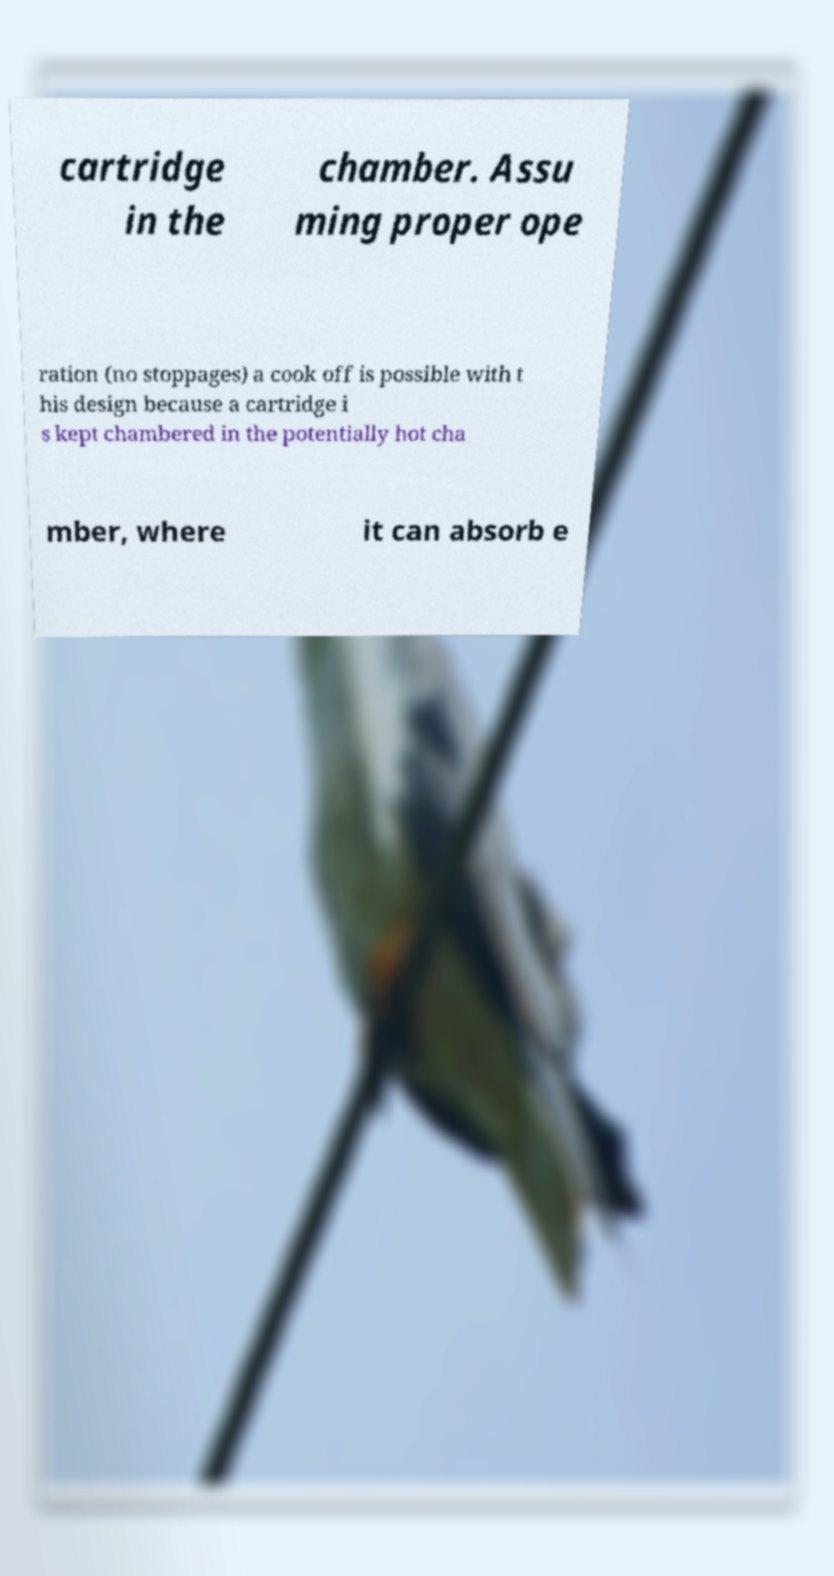What messages or text are displayed in this image? I need them in a readable, typed format. cartridge in the chamber. Assu ming proper ope ration (no stoppages) a cook off is possible with t his design because a cartridge i s kept chambered in the potentially hot cha mber, where it can absorb e 